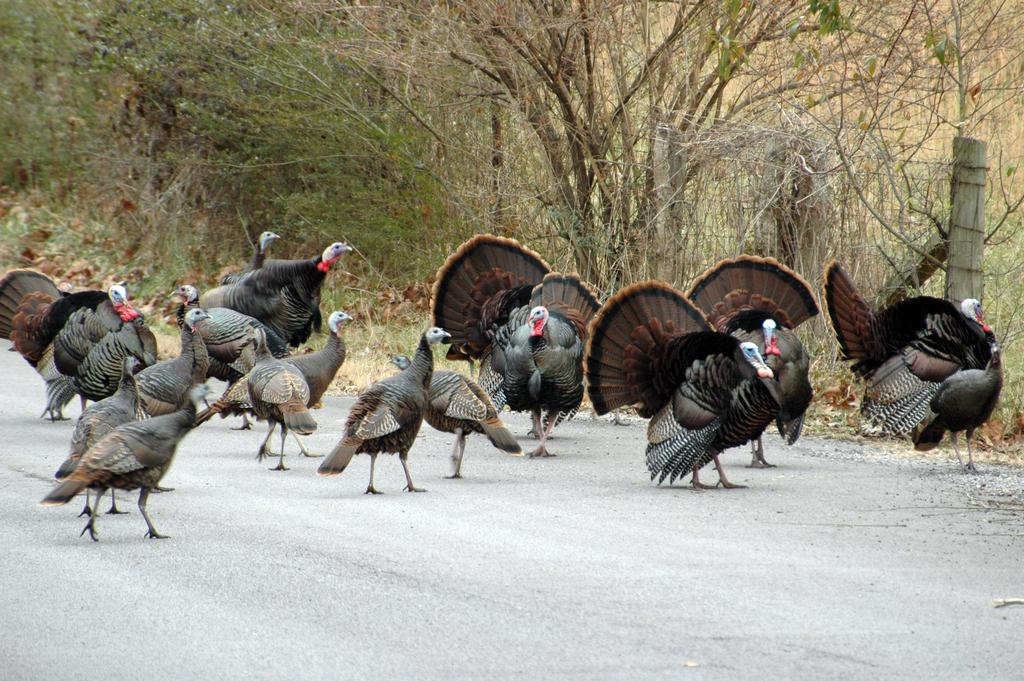What animals can be seen on the road in the image? There are turkey birds on the road in the image. What type of vegetation is visible in the background of the image? There are trees in the background of the image. What structures can be seen in the background of the image? There is a pole and a fence in the background of the image. Where is the oven located in the image? There is no oven present in the image. Can you describe the wood used to build the fence in the image? There is no information about the type of wood used to build the fence in the image. 